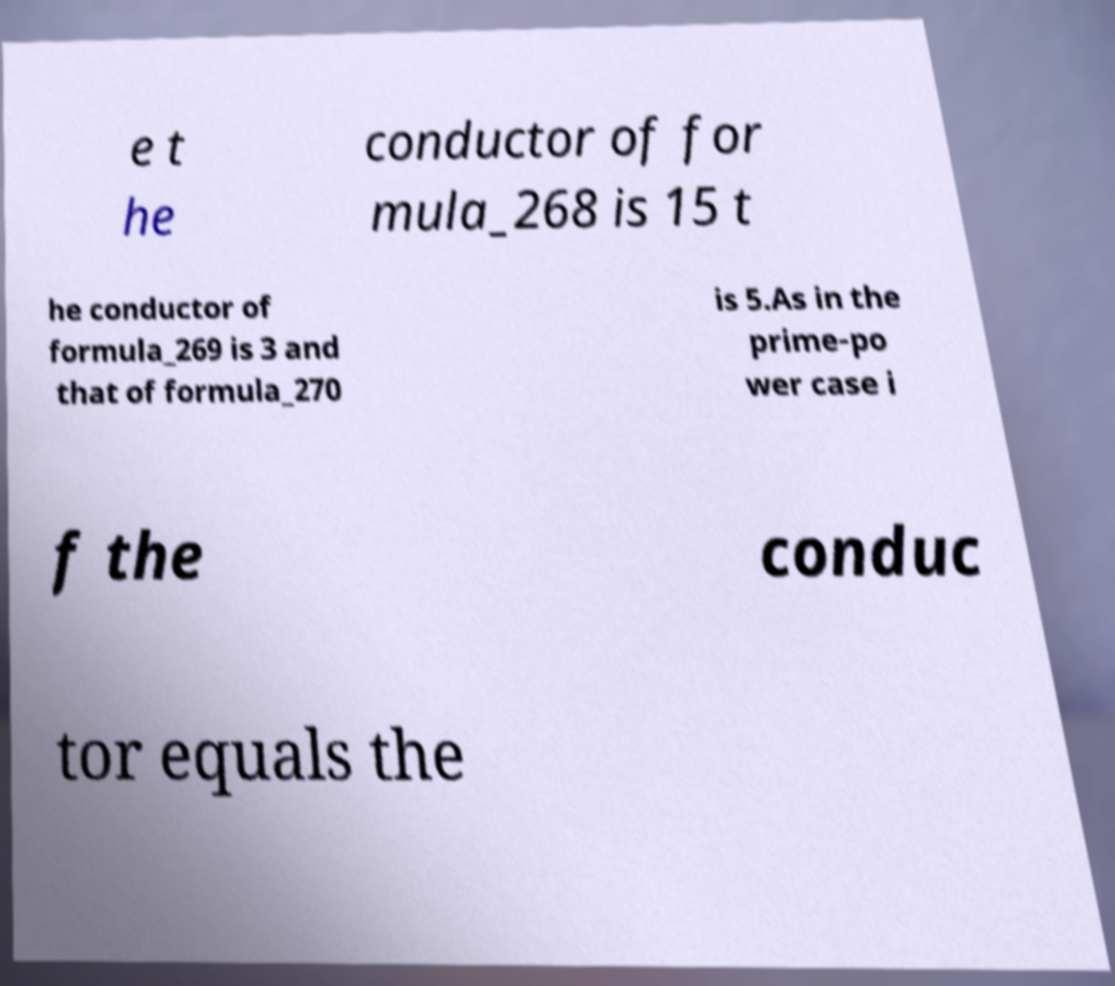Can you read and provide the text displayed in the image?This photo seems to have some interesting text. Can you extract and type it out for me? e t he conductor of for mula_268 is 15 t he conductor of formula_269 is 3 and that of formula_270 is 5.As in the prime-po wer case i f the conduc tor equals the 